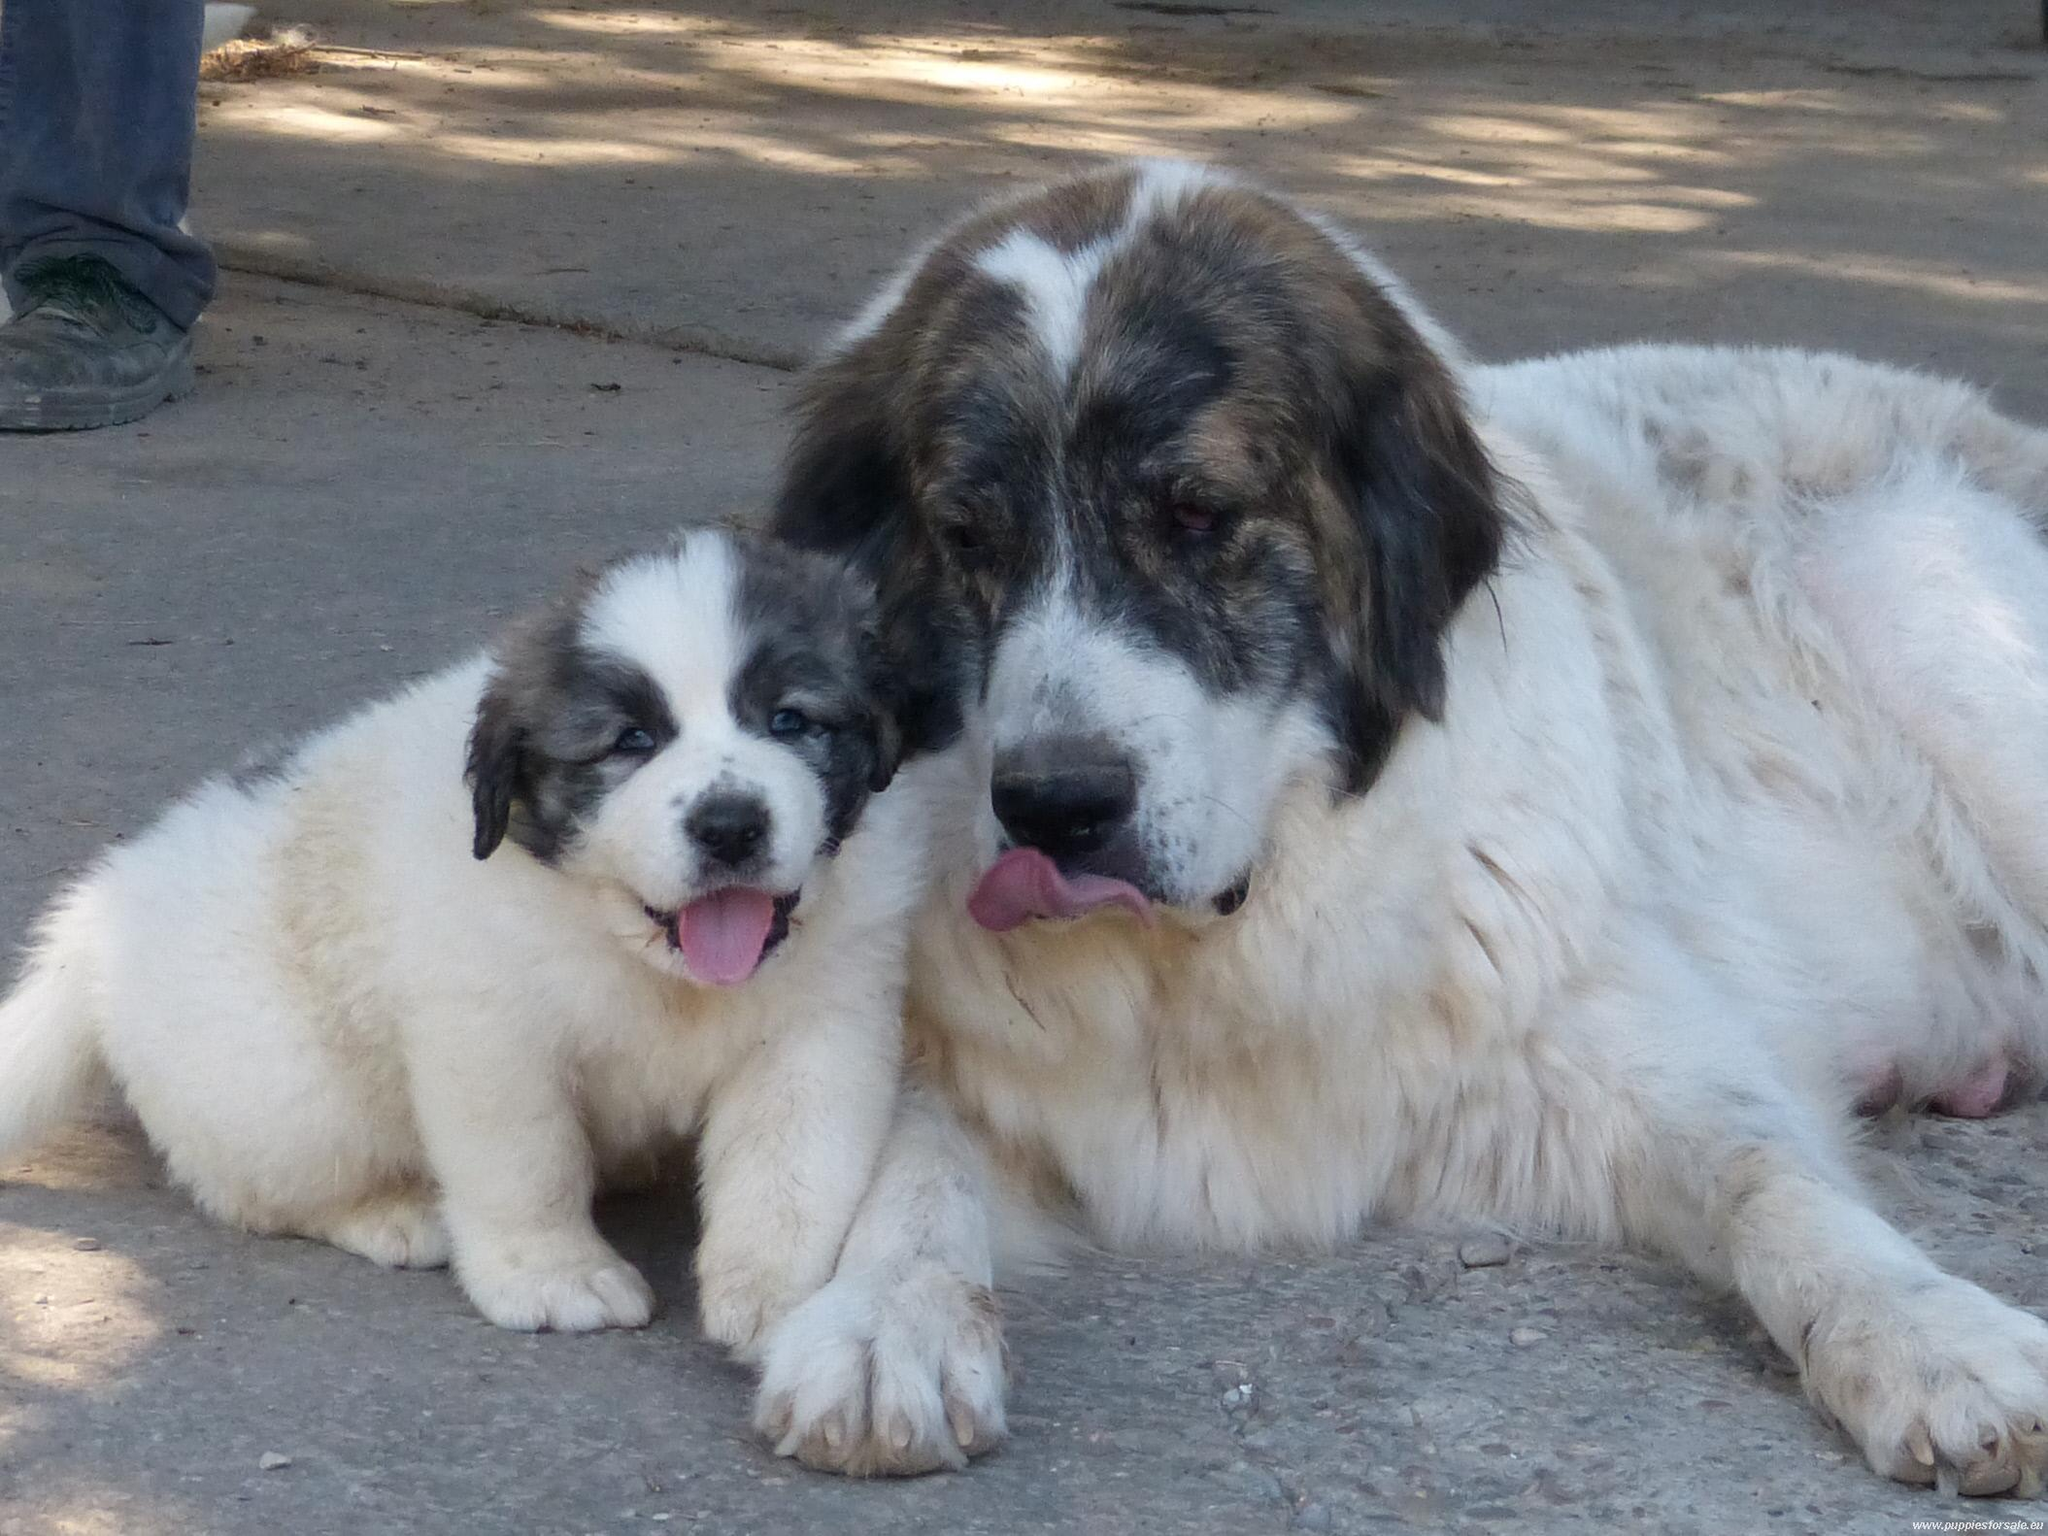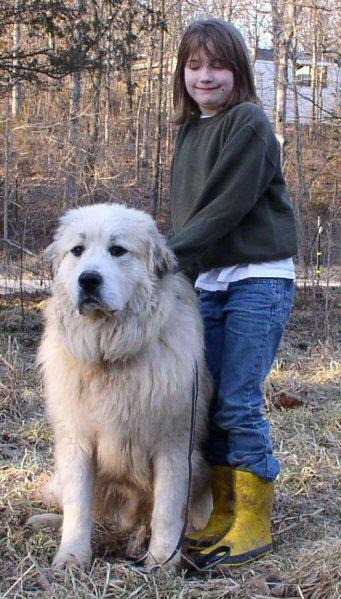The first image is the image on the left, the second image is the image on the right. Examine the images to the left and right. Is the description "there is a person near a dog in the image on the right side." accurate? Answer yes or no. Yes. The first image is the image on the left, the second image is the image on the right. Given the left and right images, does the statement "On of the images contains a young girl in a green sweater with a large white dog." hold true? Answer yes or no. Yes. 